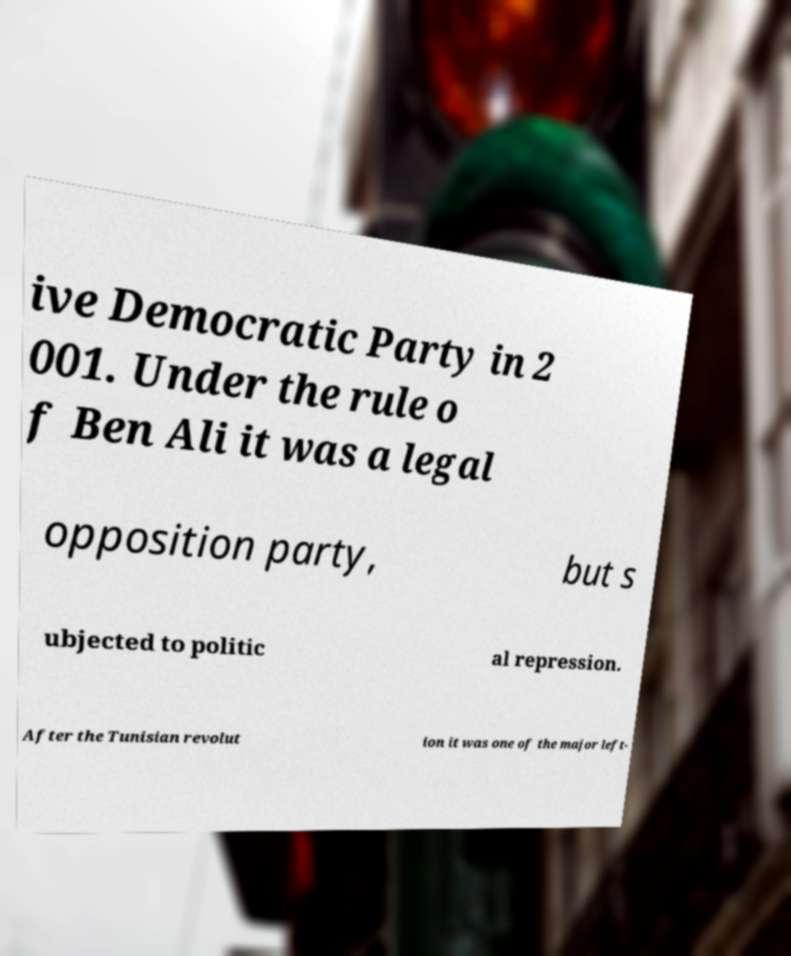Could you assist in decoding the text presented in this image and type it out clearly? ive Democratic Party in 2 001. Under the rule o f Ben Ali it was a legal opposition party, but s ubjected to politic al repression. After the Tunisian revolut ion it was one of the major left- 